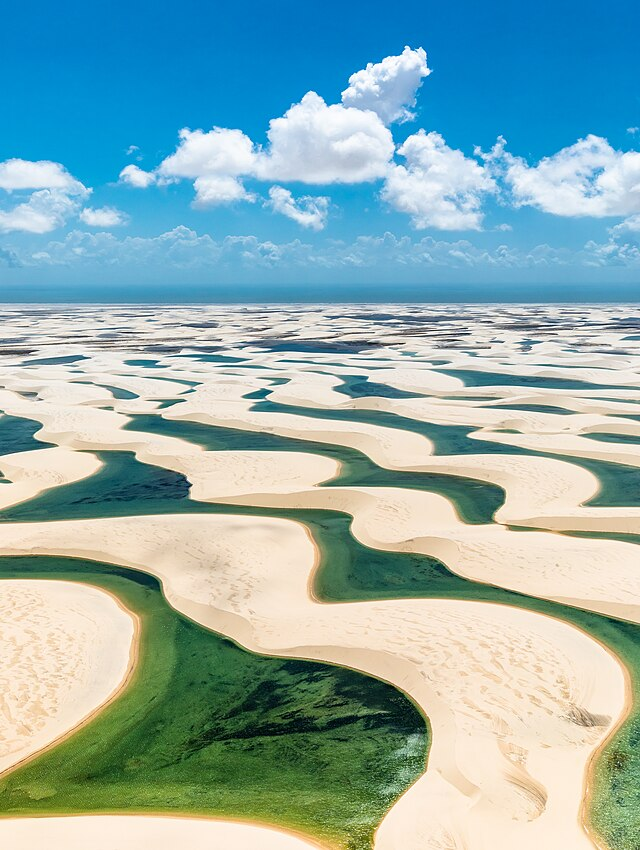What do you think is going on in this snapshot?
 The image captures the breathtaking beauty of the Lençóis Maranhenses National Park in Brazil. This unique landscape is characterized by vast expanses of pristine white sand dunes, which are interspersed with seasonal rainwater lagoons. The lagoons, filled with water, exhibit a stunning blue-green hue, providing a stark contrast to the white sand dunes. The aerial perspective of the image allows for a comprehensive view of the park, showcasing the undulating pattern of the dunes and the scattered placement of the lagoons. Above, the sky is a bright blue canvas dotted with fluffy white clouds, completing the picturesque scene. The image is a testament to the natural wonders of the Lençóis Maranhenses National Park, a landmark that stands as a testament to Brazil's diverse ecological beauty. 